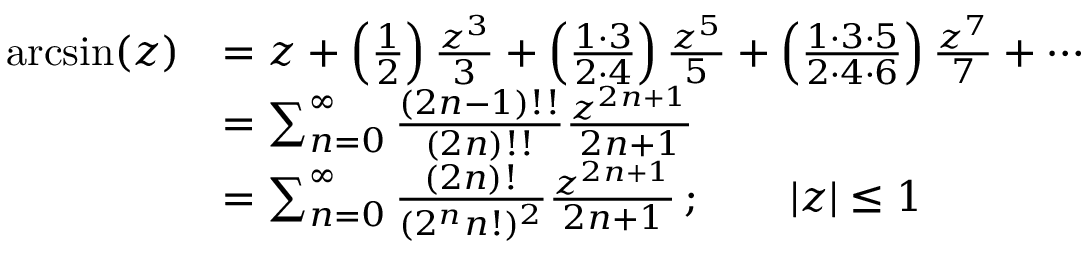Convert formula to latex. <formula><loc_0><loc_0><loc_500><loc_500>{ \begin{array} { r l } { \arcsin ( z ) } & { = z + \left ( { \frac { 1 } { 2 } } \right ) { \frac { z ^ { 3 } } { 3 } } + \left ( { \frac { 1 \cdot 3 } { 2 \cdot 4 } } \right ) { \frac { z ^ { 5 } } { 5 } } + \left ( { \frac { 1 \cdot 3 \cdot 5 } { 2 \cdot 4 \cdot 6 } } \right ) { \frac { z ^ { 7 } } { 7 } } + \cdots } \\ & { = \sum _ { n = 0 } ^ { \infty } { \frac { ( 2 n - 1 ) ! ! } { ( 2 n ) ! ! } } { \frac { z ^ { 2 n + 1 } } { 2 n + 1 } } } \\ & { = \sum _ { n = 0 } ^ { \infty } { \frac { ( 2 n ) ! } { ( 2 ^ { n } n ! ) ^ { 2 } } } { \frac { z ^ { 2 n + 1 } } { 2 n + 1 } } \, ; \quad | z | \leq 1 } \end{array} }</formula> 